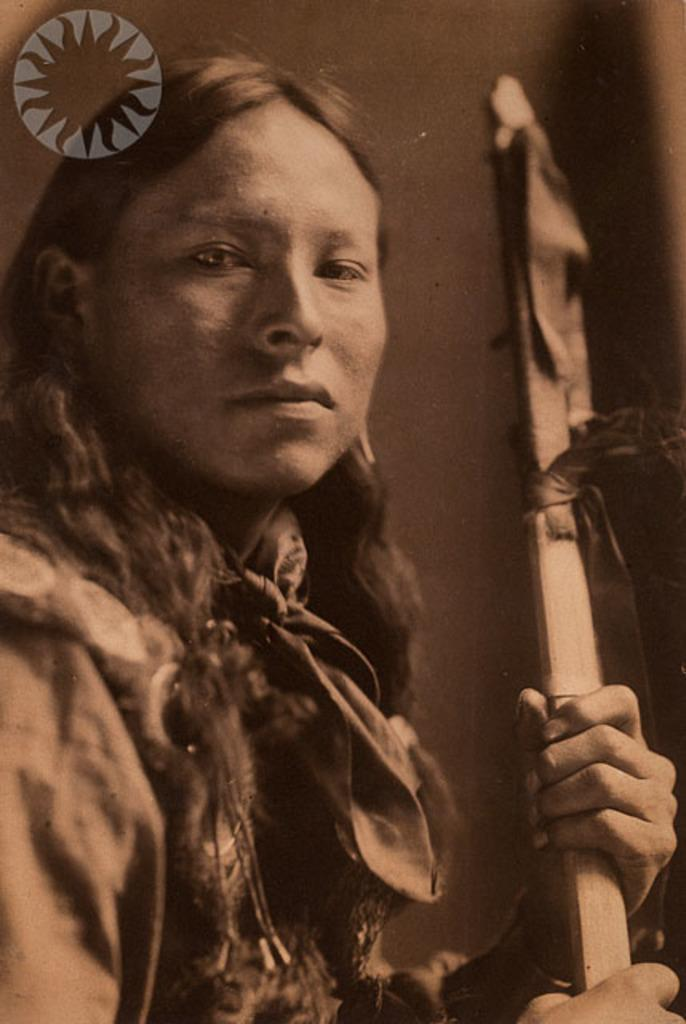What is the main subject of the image? There is a human in the image. What is the human doing in the image? The human is holding sticks in their hands. Can you describe any additional features of the image? There is a watermark in the top left corner of the image. What type of haircut does the human have in the image? There is no information about the human's haircut in the image. 